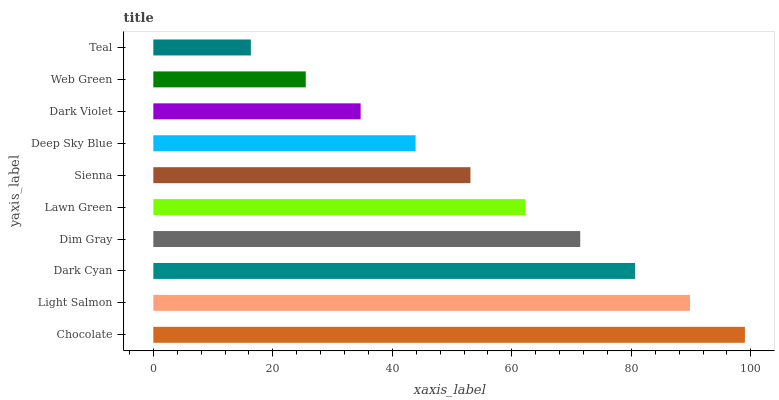Is Teal the minimum?
Answer yes or no. Yes. Is Chocolate the maximum?
Answer yes or no. Yes. Is Light Salmon the minimum?
Answer yes or no. No. Is Light Salmon the maximum?
Answer yes or no. No. Is Chocolate greater than Light Salmon?
Answer yes or no. Yes. Is Light Salmon less than Chocolate?
Answer yes or no. Yes. Is Light Salmon greater than Chocolate?
Answer yes or no. No. Is Chocolate less than Light Salmon?
Answer yes or no. No. Is Lawn Green the high median?
Answer yes or no. Yes. Is Sienna the low median?
Answer yes or no. Yes. Is Web Green the high median?
Answer yes or no. No. Is Lawn Green the low median?
Answer yes or no. No. 